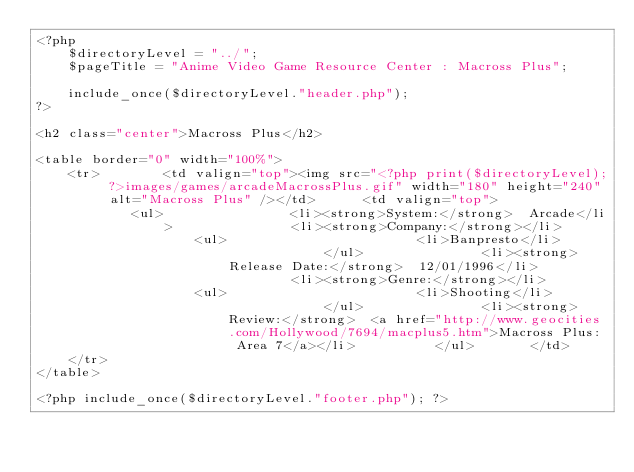<code> <loc_0><loc_0><loc_500><loc_500><_PHP_><?php
	$directoryLevel = "../";
	$pageTitle = "Anime Video Game Resource Center : Macross Plus";

	include_once($directoryLevel."header.php");
?>

<h2 class="center">Macross Plus</h2>

<table border="0" width="100%">
	<tr>		<td valign="top"><img src="<?php print($directoryLevel); ?>images/games/arcadeMacrossPlus.gif" width="180" height="240" alt="Macross Plus" /></td>		<td valign="top">
			<ul>				<li><strong>System:</strong>  Arcade</li>				<li><strong>Company:</strong></li>
					<ul>						<li>Banpresto</li>					</ul>				<li><strong>Release Date:</strong>  12/01/1996</li>				<li><strong>Genre:</strong></li>
					<ul>						<li>Shooting</li>					</ul>				<li><strong>Review:</strong>  <a href="http://www.geocities.com/Hollywood/7694/macplus5.htm">Macross Plus: Area 7</a></li>			</ul>		</td>
	</tr>
</table>

<?php include_once($directoryLevel."footer.php"); ?></code> 